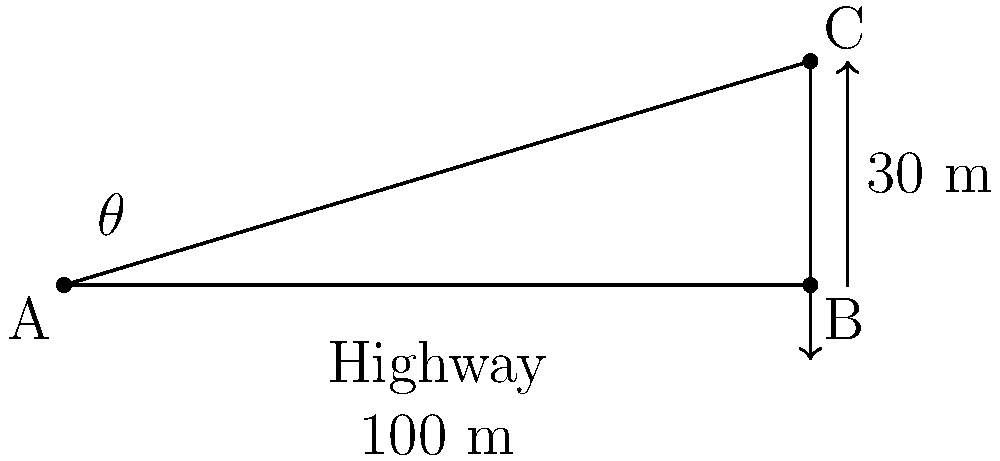As a park ranger, you're tasked with designing a wildlife crossing bridge over a highway. The bridge needs to span 100 meters across the highway and reach a height of 30 meters at its peak. What is the angle of inclination ($\theta$) for the bridge? To find the angle of inclination ($\theta$), we can use trigonometry. The bridge forms a right-angled triangle, where:

1. The base (adjacent side) is 100 meters (span of the highway)
2. The height (opposite side) is 30 meters (peak height of the bridge)
3. The hypotenuse is the length of the bridge (which we don't need to calculate for this problem)

We can use the tangent function to find the angle:

$\tan(\theta) = \frac{\text{opposite}}{\text{adjacent}} = \frac{\text{height}}{\text{base}}$

$\tan(\theta) = \frac{30}{100} = 0.3$

To find $\theta$, we need to use the inverse tangent (arctan or $\tan^{-1}$):

$\theta = \tan^{-1}(0.3)$

Using a calculator or trigonometric tables:

$\theta \approx 16.70^\circ$

This angle ensures that the wildlife crossing bridge spans the required 100 meters and reaches the desired height of 30 meters, providing a gentle slope for animals to traverse safely.
Answer: $16.70^\circ$ 